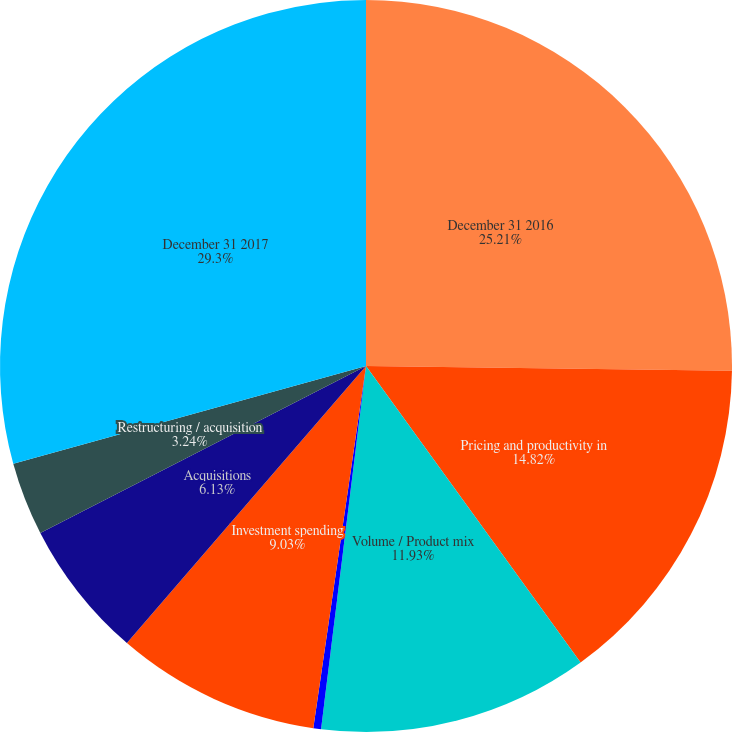Convert chart to OTSL. <chart><loc_0><loc_0><loc_500><loc_500><pie_chart><fcel>December 31 2016<fcel>Pricing and productivity in<fcel>Volume / Product mix<fcel>Currency exchange rates<fcel>Investment spending<fcel>Acquisitions<fcel>Restructuring / acquisition<fcel>December 31 2017<nl><fcel>25.21%<fcel>14.82%<fcel>11.93%<fcel>0.34%<fcel>9.03%<fcel>6.13%<fcel>3.24%<fcel>29.3%<nl></chart> 